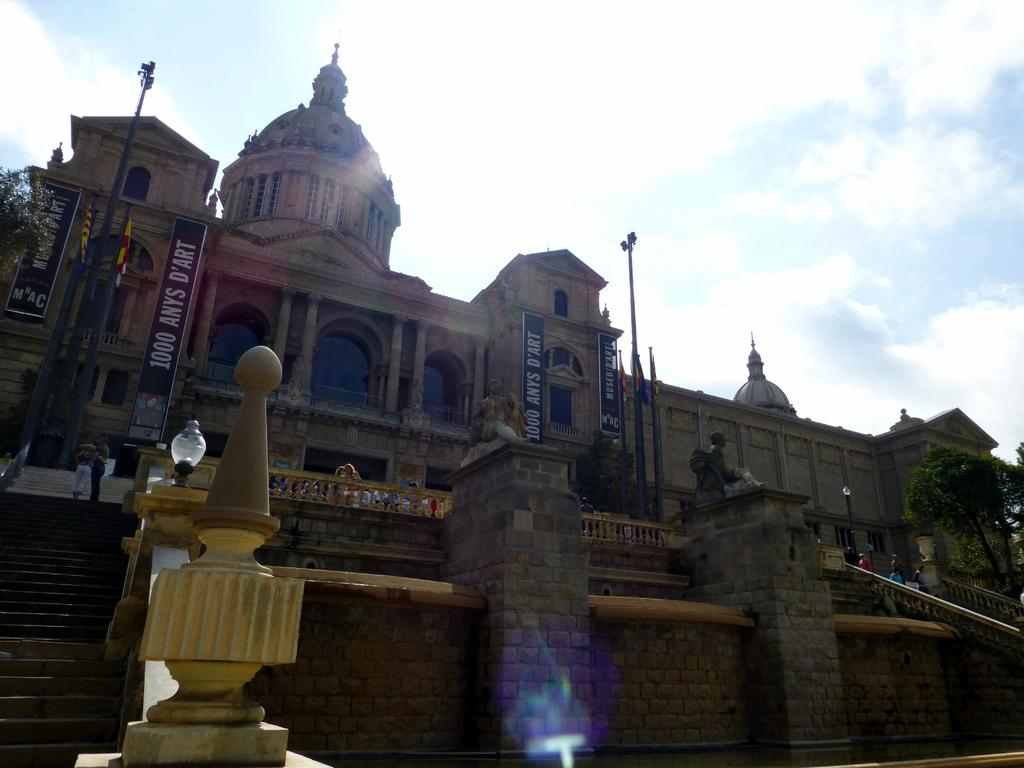What can be seen in the background of the image? The sky is visible in the background of the image. What type of structure is present in the image? There is a building in the image. What type of vegetation is present in the image? Trees are present in the image. Are there any people in the image? Yes, there are people in the image. What type of architectural feature can be seen in the image? Concrete railings are visible in the image. What additional decorative elements are present in the image? Banners and flags are present in the image. What type of support structures are visible in the image? Poles and pillars are visible in the image. Are there any statues in the image? Yes, statues are present in the image. What type of lighting is visible in the image? Lights are visible in the image. What type of account is being discussed in the image? There is no mention of an account in the image; it features a building, trees, people, and various architectural and decorative elements. 